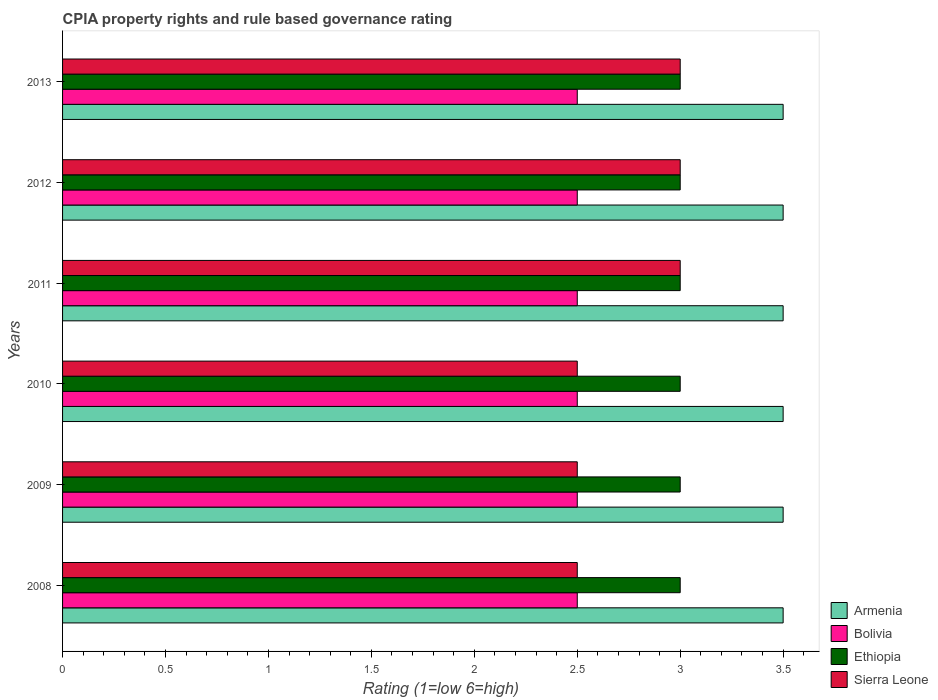How many groups of bars are there?
Give a very brief answer. 6. Are the number of bars on each tick of the Y-axis equal?
Offer a terse response. Yes. How many bars are there on the 1st tick from the bottom?
Ensure brevity in your answer.  4. What is the CPIA rating in Bolivia in 2010?
Your answer should be very brief. 2.5. Across all years, what is the maximum CPIA rating in Sierra Leone?
Keep it short and to the point. 3. Across all years, what is the minimum CPIA rating in Bolivia?
Provide a succinct answer. 2.5. In which year was the CPIA rating in Ethiopia minimum?
Provide a short and direct response. 2008. What is the total CPIA rating in Sierra Leone in the graph?
Your answer should be compact. 16.5. What is the difference between the CPIA rating in Armenia in 2010 and the CPIA rating in Ethiopia in 2011?
Make the answer very short. 0.5. What is the average CPIA rating in Armenia per year?
Your answer should be compact. 3.5. In the year 2008, what is the difference between the CPIA rating in Ethiopia and CPIA rating in Bolivia?
Provide a short and direct response. 0.5. What is the ratio of the CPIA rating in Sierra Leone in 2008 to that in 2012?
Your response must be concise. 0.83. Is the difference between the CPIA rating in Ethiopia in 2009 and 2013 greater than the difference between the CPIA rating in Bolivia in 2009 and 2013?
Give a very brief answer. No. What is the difference between the highest and the second highest CPIA rating in Armenia?
Ensure brevity in your answer.  0. What is the difference between the highest and the lowest CPIA rating in Sierra Leone?
Make the answer very short. 0.5. In how many years, is the CPIA rating in Ethiopia greater than the average CPIA rating in Ethiopia taken over all years?
Offer a terse response. 0. Is the sum of the CPIA rating in Ethiopia in 2009 and 2013 greater than the maximum CPIA rating in Sierra Leone across all years?
Provide a short and direct response. Yes. What does the 3rd bar from the top in 2010 represents?
Make the answer very short. Bolivia. What does the 4th bar from the bottom in 2008 represents?
Your answer should be very brief. Sierra Leone. How many years are there in the graph?
Your answer should be very brief. 6. What is the difference between two consecutive major ticks on the X-axis?
Ensure brevity in your answer.  0.5. Are the values on the major ticks of X-axis written in scientific E-notation?
Your answer should be very brief. No. Does the graph contain any zero values?
Give a very brief answer. No. Does the graph contain grids?
Your answer should be very brief. No. Where does the legend appear in the graph?
Ensure brevity in your answer.  Bottom right. What is the title of the graph?
Give a very brief answer. CPIA property rights and rule based governance rating. What is the label or title of the Y-axis?
Ensure brevity in your answer.  Years. What is the Rating (1=low 6=high) of Armenia in 2009?
Offer a very short reply. 3.5. What is the Rating (1=low 6=high) in Armenia in 2010?
Provide a short and direct response. 3.5. What is the Rating (1=low 6=high) in Sierra Leone in 2010?
Make the answer very short. 2.5. What is the Rating (1=low 6=high) in Armenia in 2011?
Your answer should be compact. 3.5. What is the Rating (1=low 6=high) of Bolivia in 2011?
Offer a terse response. 2.5. What is the Rating (1=low 6=high) in Ethiopia in 2011?
Offer a very short reply. 3. What is the Rating (1=low 6=high) of Sierra Leone in 2011?
Your response must be concise. 3. What is the Rating (1=low 6=high) of Armenia in 2012?
Give a very brief answer. 3.5. What is the Rating (1=low 6=high) in Bolivia in 2012?
Give a very brief answer. 2.5. What is the Rating (1=low 6=high) in Sierra Leone in 2012?
Provide a short and direct response. 3. What is the Rating (1=low 6=high) of Ethiopia in 2013?
Ensure brevity in your answer.  3. Across all years, what is the maximum Rating (1=low 6=high) of Bolivia?
Give a very brief answer. 2.5. Across all years, what is the maximum Rating (1=low 6=high) in Ethiopia?
Offer a very short reply. 3. Across all years, what is the maximum Rating (1=low 6=high) of Sierra Leone?
Keep it short and to the point. 3. Across all years, what is the minimum Rating (1=low 6=high) of Armenia?
Your response must be concise. 3.5. Across all years, what is the minimum Rating (1=low 6=high) in Bolivia?
Make the answer very short. 2.5. What is the total Rating (1=low 6=high) of Armenia in the graph?
Offer a very short reply. 21. What is the total Rating (1=low 6=high) of Ethiopia in the graph?
Make the answer very short. 18. What is the total Rating (1=low 6=high) of Sierra Leone in the graph?
Keep it short and to the point. 16.5. What is the difference between the Rating (1=low 6=high) of Armenia in 2008 and that in 2009?
Offer a very short reply. 0. What is the difference between the Rating (1=low 6=high) of Bolivia in 2008 and that in 2009?
Give a very brief answer. 0. What is the difference between the Rating (1=low 6=high) in Ethiopia in 2008 and that in 2009?
Your answer should be very brief. 0. What is the difference between the Rating (1=low 6=high) in Armenia in 2008 and that in 2010?
Provide a succinct answer. 0. What is the difference between the Rating (1=low 6=high) in Sierra Leone in 2008 and that in 2010?
Keep it short and to the point. 0. What is the difference between the Rating (1=low 6=high) of Armenia in 2008 and that in 2011?
Make the answer very short. 0. What is the difference between the Rating (1=low 6=high) in Armenia in 2008 and that in 2012?
Your answer should be very brief. 0. What is the difference between the Rating (1=low 6=high) of Bolivia in 2008 and that in 2012?
Keep it short and to the point. 0. What is the difference between the Rating (1=low 6=high) of Ethiopia in 2008 and that in 2012?
Offer a terse response. 0. What is the difference between the Rating (1=low 6=high) in Sierra Leone in 2008 and that in 2012?
Ensure brevity in your answer.  -0.5. What is the difference between the Rating (1=low 6=high) in Armenia in 2008 and that in 2013?
Keep it short and to the point. 0. What is the difference between the Rating (1=low 6=high) of Bolivia in 2008 and that in 2013?
Make the answer very short. 0. What is the difference between the Rating (1=low 6=high) of Ethiopia in 2008 and that in 2013?
Make the answer very short. 0. What is the difference between the Rating (1=low 6=high) in Sierra Leone in 2008 and that in 2013?
Offer a very short reply. -0.5. What is the difference between the Rating (1=low 6=high) in Bolivia in 2009 and that in 2010?
Keep it short and to the point. 0. What is the difference between the Rating (1=low 6=high) in Ethiopia in 2009 and that in 2010?
Keep it short and to the point. 0. What is the difference between the Rating (1=low 6=high) in Sierra Leone in 2009 and that in 2010?
Ensure brevity in your answer.  0. What is the difference between the Rating (1=low 6=high) of Bolivia in 2009 and that in 2012?
Your answer should be compact. 0. What is the difference between the Rating (1=low 6=high) in Ethiopia in 2009 and that in 2012?
Keep it short and to the point. 0. What is the difference between the Rating (1=low 6=high) of Armenia in 2009 and that in 2013?
Offer a terse response. 0. What is the difference between the Rating (1=low 6=high) in Bolivia in 2009 and that in 2013?
Your answer should be compact. 0. What is the difference between the Rating (1=low 6=high) of Sierra Leone in 2010 and that in 2011?
Offer a very short reply. -0.5. What is the difference between the Rating (1=low 6=high) of Armenia in 2010 and that in 2012?
Ensure brevity in your answer.  0. What is the difference between the Rating (1=low 6=high) in Ethiopia in 2010 and that in 2012?
Provide a succinct answer. 0. What is the difference between the Rating (1=low 6=high) of Sierra Leone in 2010 and that in 2012?
Provide a short and direct response. -0.5. What is the difference between the Rating (1=low 6=high) in Armenia in 2010 and that in 2013?
Your answer should be compact. 0. What is the difference between the Rating (1=low 6=high) in Bolivia in 2010 and that in 2013?
Your answer should be very brief. 0. What is the difference between the Rating (1=low 6=high) of Sierra Leone in 2010 and that in 2013?
Your response must be concise. -0.5. What is the difference between the Rating (1=low 6=high) of Armenia in 2011 and that in 2012?
Ensure brevity in your answer.  0. What is the difference between the Rating (1=low 6=high) of Bolivia in 2011 and that in 2012?
Your response must be concise. 0. What is the difference between the Rating (1=low 6=high) in Sierra Leone in 2011 and that in 2012?
Your answer should be very brief. 0. What is the difference between the Rating (1=low 6=high) in Ethiopia in 2011 and that in 2013?
Your answer should be very brief. 0. What is the difference between the Rating (1=low 6=high) in Sierra Leone in 2011 and that in 2013?
Keep it short and to the point. 0. What is the difference between the Rating (1=low 6=high) of Armenia in 2012 and that in 2013?
Offer a very short reply. 0. What is the difference between the Rating (1=low 6=high) in Ethiopia in 2012 and that in 2013?
Provide a succinct answer. 0. What is the difference between the Rating (1=low 6=high) in Sierra Leone in 2012 and that in 2013?
Provide a short and direct response. 0. What is the difference between the Rating (1=low 6=high) of Armenia in 2008 and the Rating (1=low 6=high) of Bolivia in 2009?
Provide a short and direct response. 1. What is the difference between the Rating (1=low 6=high) in Armenia in 2008 and the Rating (1=low 6=high) in Sierra Leone in 2009?
Your answer should be very brief. 1. What is the difference between the Rating (1=low 6=high) in Armenia in 2008 and the Rating (1=low 6=high) in Bolivia in 2010?
Offer a terse response. 1. What is the difference between the Rating (1=low 6=high) of Armenia in 2008 and the Rating (1=low 6=high) of Sierra Leone in 2010?
Provide a succinct answer. 1. What is the difference between the Rating (1=low 6=high) of Bolivia in 2008 and the Rating (1=low 6=high) of Ethiopia in 2010?
Give a very brief answer. -0.5. What is the difference between the Rating (1=low 6=high) of Armenia in 2008 and the Rating (1=low 6=high) of Ethiopia in 2011?
Your response must be concise. 0.5. What is the difference between the Rating (1=low 6=high) in Armenia in 2008 and the Rating (1=low 6=high) in Sierra Leone in 2011?
Your answer should be very brief. 0.5. What is the difference between the Rating (1=low 6=high) of Bolivia in 2008 and the Rating (1=low 6=high) of Sierra Leone in 2011?
Make the answer very short. -0.5. What is the difference between the Rating (1=low 6=high) of Armenia in 2008 and the Rating (1=low 6=high) of Ethiopia in 2012?
Make the answer very short. 0.5. What is the difference between the Rating (1=low 6=high) in Armenia in 2008 and the Rating (1=low 6=high) in Sierra Leone in 2012?
Make the answer very short. 0.5. What is the difference between the Rating (1=low 6=high) of Armenia in 2008 and the Rating (1=low 6=high) of Sierra Leone in 2013?
Provide a short and direct response. 0.5. What is the difference between the Rating (1=low 6=high) of Armenia in 2009 and the Rating (1=low 6=high) of Bolivia in 2010?
Give a very brief answer. 1. What is the difference between the Rating (1=low 6=high) in Armenia in 2009 and the Rating (1=low 6=high) in Ethiopia in 2010?
Give a very brief answer. 0.5. What is the difference between the Rating (1=low 6=high) of Armenia in 2009 and the Rating (1=low 6=high) of Sierra Leone in 2010?
Keep it short and to the point. 1. What is the difference between the Rating (1=low 6=high) in Bolivia in 2009 and the Rating (1=low 6=high) in Ethiopia in 2010?
Your answer should be very brief. -0.5. What is the difference between the Rating (1=low 6=high) of Bolivia in 2009 and the Rating (1=low 6=high) of Sierra Leone in 2010?
Your answer should be very brief. 0. What is the difference between the Rating (1=low 6=high) of Ethiopia in 2009 and the Rating (1=low 6=high) of Sierra Leone in 2010?
Give a very brief answer. 0.5. What is the difference between the Rating (1=low 6=high) in Bolivia in 2009 and the Rating (1=low 6=high) in Sierra Leone in 2011?
Your answer should be very brief. -0.5. What is the difference between the Rating (1=low 6=high) in Ethiopia in 2009 and the Rating (1=low 6=high) in Sierra Leone in 2011?
Your answer should be very brief. 0. What is the difference between the Rating (1=low 6=high) in Armenia in 2009 and the Rating (1=low 6=high) in Bolivia in 2012?
Your answer should be very brief. 1. What is the difference between the Rating (1=low 6=high) of Bolivia in 2009 and the Rating (1=low 6=high) of Ethiopia in 2012?
Make the answer very short. -0.5. What is the difference between the Rating (1=low 6=high) of Ethiopia in 2009 and the Rating (1=low 6=high) of Sierra Leone in 2012?
Your answer should be compact. 0. What is the difference between the Rating (1=low 6=high) in Bolivia in 2009 and the Rating (1=low 6=high) in Sierra Leone in 2013?
Ensure brevity in your answer.  -0.5. What is the difference between the Rating (1=low 6=high) of Bolivia in 2010 and the Rating (1=low 6=high) of Sierra Leone in 2011?
Offer a very short reply. -0.5. What is the difference between the Rating (1=low 6=high) in Armenia in 2010 and the Rating (1=low 6=high) in Bolivia in 2012?
Offer a terse response. 1. What is the difference between the Rating (1=low 6=high) of Bolivia in 2010 and the Rating (1=low 6=high) of Ethiopia in 2012?
Provide a short and direct response. -0.5. What is the difference between the Rating (1=low 6=high) in Bolivia in 2010 and the Rating (1=low 6=high) in Ethiopia in 2013?
Provide a short and direct response. -0.5. What is the difference between the Rating (1=low 6=high) of Ethiopia in 2010 and the Rating (1=low 6=high) of Sierra Leone in 2013?
Your answer should be very brief. 0. What is the difference between the Rating (1=low 6=high) of Armenia in 2011 and the Rating (1=low 6=high) of Bolivia in 2012?
Offer a terse response. 1. What is the difference between the Rating (1=low 6=high) in Armenia in 2011 and the Rating (1=low 6=high) in Ethiopia in 2012?
Provide a succinct answer. 0.5. What is the difference between the Rating (1=low 6=high) in Ethiopia in 2011 and the Rating (1=low 6=high) in Sierra Leone in 2012?
Your answer should be compact. 0. What is the difference between the Rating (1=low 6=high) of Armenia in 2011 and the Rating (1=low 6=high) of Ethiopia in 2013?
Provide a succinct answer. 0.5. What is the difference between the Rating (1=low 6=high) of Armenia in 2011 and the Rating (1=low 6=high) of Sierra Leone in 2013?
Your answer should be compact. 0.5. What is the difference between the Rating (1=low 6=high) in Bolivia in 2011 and the Rating (1=low 6=high) in Ethiopia in 2013?
Make the answer very short. -0.5. What is the difference between the Rating (1=low 6=high) of Armenia in 2012 and the Rating (1=low 6=high) of Bolivia in 2013?
Ensure brevity in your answer.  1. What is the difference between the Rating (1=low 6=high) in Armenia in 2012 and the Rating (1=low 6=high) in Ethiopia in 2013?
Your answer should be very brief. 0.5. What is the difference between the Rating (1=low 6=high) in Bolivia in 2012 and the Rating (1=low 6=high) in Ethiopia in 2013?
Offer a very short reply. -0.5. What is the difference between the Rating (1=low 6=high) in Bolivia in 2012 and the Rating (1=low 6=high) in Sierra Leone in 2013?
Offer a terse response. -0.5. What is the difference between the Rating (1=low 6=high) in Ethiopia in 2012 and the Rating (1=low 6=high) in Sierra Leone in 2013?
Your answer should be very brief. 0. What is the average Rating (1=low 6=high) in Ethiopia per year?
Ensure brevity in your answer.  3. What is the average Rating (1=low 6=high) in Sierra Leone per year?
Your answer should be very brief. 2.75. In the year 2008, what is the difference between the Rating (1=low 6=high) in Armenia and Rating (1=low 6=high) in Bolivia?
Your response must be concise. 1. In the year 2008, what is the difference between the Rating (1=low 6=high) of Bolivia and Rating (1=low 6=high) of Ethiopia?
Make the answer very short. -0.5. In the year 2009, what is the difference between the Rating (1=low 6=high) in Armenia and Rating (1=low 6=high) in Ethiopia?
Provide a short and direct response. 0.5. In the year 2010, what is the difference between the Rating (1=low 6=high) of Armenia and Rating (1=low 6=high) of Bolivia?
Your answer should be compact. 1. In the year 2010, what is the difference between the Rating (1=low 6=high) in Armenia and Rating (1=low 6=high) in Ethiopia?
Your answer should be compact. 0.5. In the year 2010, what is the difference between the Rating (1=low 6=high) in Armenia and Rating (1=low 6=high) in Sierra Leone?
Keep it short and to the point. 1. In the year 2010, what is the difference between the Rating (1=low 6=high) of Bolivia and Rating (1=low 6=high) of Sierra Leone?
Provide a short and direct response. 0. In the year 2011, what is the difference between the Rating (1=low 6=high) of Bolivia and Rating (1=low 6=high) of Sierra Leone?
Keep it short and to the point. -0.5. In the year 2012, what is the difference between the Rating (1=low 6=high) of Armenia and Rating (1=low 6=high) of Ethiopia?
Offer a terse response. 0.5. In the year 2012, what is the difference between the Rating (1=low 6=high) in Armenia and Rating (1=low 6=high) in Sierra Leone?
Give a very brief answer. 0.5. In the year 2012, what is the difference between the Rating (1=low 6=high) of Bolivia and Rating (1=low 6=high) of Ethiopia?
Keep it short and to the point. -0.5. In the year 2012, what is the difference between the Rating (1=low 6=high) of Bolivia and Rating (1=low 6=high) of Sierra Leone?
Your answer should be very brief. -0.5. In the year 2012, what is the difference between the Rating (1=low 6=high) of Ethiopia and Rating (1=low 6=high) of Sierra Leone?
Offer a terse response. 0. In the year 2013, what is the difference between the Rating (1=low 6=high) of Armenia and Rating (1=low 6=high) of Bolivia?
Your answer should be very brief. 1. In the year 2013, what is the difference between the Rating (1=low 6=high) of Armenia and Rating (1=low 6=high) of Ethiopia?
Offer a terse response. 0.5. In the year 2013, what is the difference between the Rating (1=low 6=high) in Bolivia and Rating (1=low 6=high) in Ethiopia?
Provide a short and direct response. -0.5. In the year 2013, what is the difference between the Rating (1=low 6=high) in Bolivia and Rating (1=low 6=high) in Sierra Leone?
Your response must be concise. -0.5. In the year 2013, what is the difference between the Rating (1=low 6=high) of Ethiopia and Rating (1=low 6=high) of Sierra Leone?
Provide a succinct answer. 0. What is the ratio of the Rating (1=low 6=high) in Bolivia in 2008 to that in 2009?
Ensure brevity in your answer.  1. What is the ratio of the Rating (1=low 6=high) of Ethiopia in 2008 to that in 2009?
Keep it short and to the point. 1. What is the ratio of the Rating (1=low 6=high) of Sierra Leone in 2008 to that in 2009?
Offer a very short reply. 1. What is the ratio of the Rating (1=low 6=high) of Armenia in 2008 to that in 2010?
Ensure brevity in your answer.  1. What is the ratio of the Rating (1=low 6=high) of Armenia in 2008 to that in 2011?
Your response must be concise. 1. What is the ratio of the Rating (1=low 6=high) in Bolivia in 2008 to that in 2011?
Provide a short and direct response. 1. What is the ratio of the Rating (1=low 6=high) in Sierra Leone in 2008 to that in 2011?
Your answer should be compact. 0.83. What is the ratio of the Rating (1=low 6=high) in Bolivia in 2008 to that in 2012?
Your response must be concise. 1. What is the ratio of the Rating (1=low 6=high) in Ethiopia in 2008 to that in 2012?
Offer a terse response. 1. What is the ratio of the Rating (1=low 6=high) in Armenia in 2008 to that in 2013?
Offer a very short reply. 1. What is the ratio of the Rating (1=low 6=high) in Bolivia in 2008 to that in 2013?
Provide a succinct answer. 1. What is the ratio of the Rating (1=low 6=high) in Ethiopia in 2008 to that in 2013?
Ensure brevity in your answer.  1. What is the ratio of the Rating (1=low 6=high) of Sierra Leone in 2008 to that in 2013?
Make the answer very short. 0.83. What is the ratio of the Rating (1=low 6=high) of Ethiopia in 2009 to that in 2010?
Your answer should be compact. 1. What is the ratio of the Rating (1=low 6=high) of Bolivia in 2009 to that in 2011?
Offer a terse response. 1. What is the ratio of the Rating (1=low 6=high) of Ethiopia in 2009 to that in 2011?
Provide a succinct answer. 1. What is the ratio of the Rating (1=low 6=high) of Bolivia in 2009 to that in 2012?
Provide a short and direct response. 1. What is the ratio of the Rating (1=low 6=high) in Ethiopia in 2009 to that in 2012?
Make the answer very short. 1. What is the ratio of the Rating (1=low 6=high) in Sierra Leone in 2009 to that in 2013?
Make the answer very short. 0.83. What is the ratio of the Rating (1=low 6=high) of Armenia in 2010 to that in 2011?
Keep it short and to the point. 1. What is the ratio of the Rating (1=low 6=high) in Bolivia in 2010 to that in 2011?
Your answer should be very brief. 1. What is the ratio of the Rating (1=low 6=high) in Ethiopia in 2010 to that in 2011?
Offer a terse response. 1. What is the ratio of the Rating (1=low 6=high) in Ethiopia in 2010 to that in 2012?
Provide a short and direct response. 1. What is the ratio of the Rating (1=low 6=high) in Sierra Leone in 2010 to that in 2013?
Offer a very short reply. 0.83. What is the ratio of the Rating (1=low 6=high) of Bolivia in 2011 to that in 2012?
Make the answer very short. 1. What is the ratio of the Rating (1=low 6=high) of Bolivia in 2011 to that in 2013?
Give a very brief answer. 1. What is the ratio of the Rating (1=low 6=high) of Armenia in 2012 to that in 2013?
Your answer should be compact. 1. What is the ratio of the Rating (1=low 6=high) in Ethiopia in 2012 to that in 2013?
Give a very brief answer. 1. What is the ratio of the Rating (1=low 6=high) in Sierra Leone in 2012 to that in 2013?
Ensure brevity in your answer.  1. What is the difference between the highest and the second highest Rating (1=low 6=high) of Ethiopia?
Your answer should be very brief. 0. What is the difference between the highest and the lowest Rating (1=low 6=high) of Armenia?
Give a very brief answer. 0. What is the difference between the highest and the lowest Rating (1=low 6=high) in Bolivia?
Keep it short and to the point. 0. What is the difference between the highest and the lowest Rating (1=low 6=high) of Sierra Leone?
Your answer should be very brief. 0.5. 